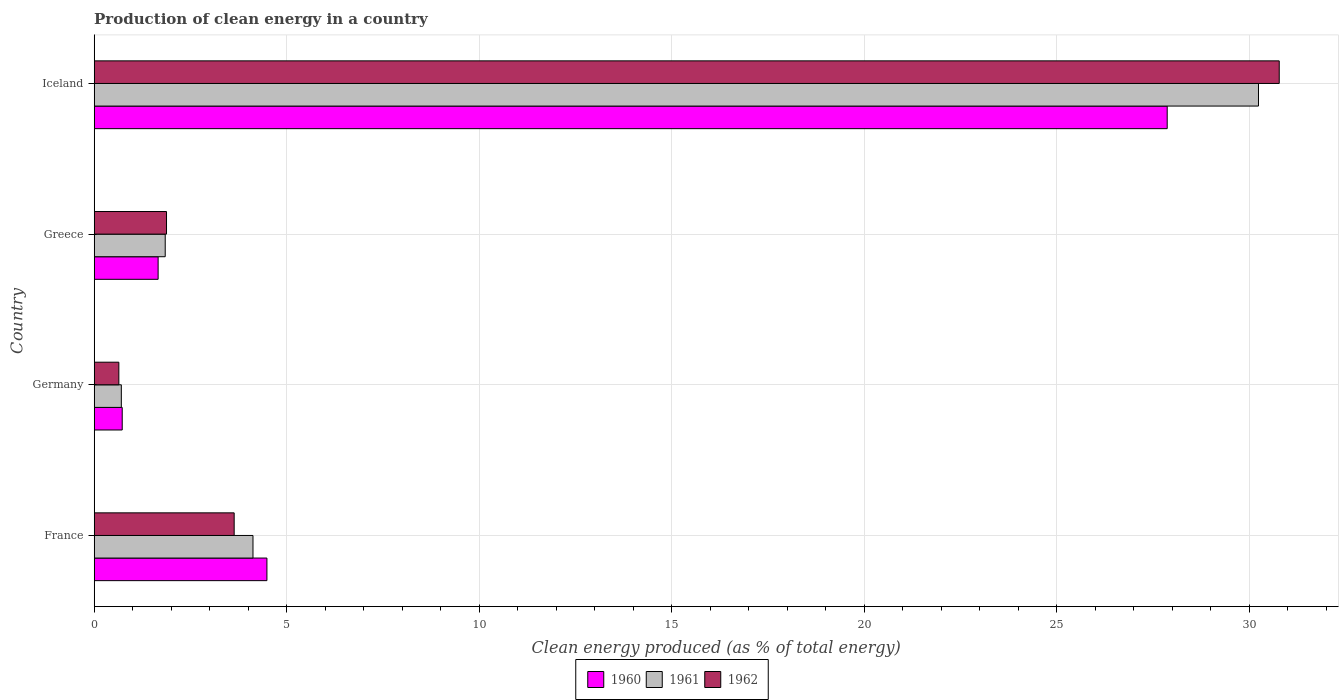How many different coloured bars are there?
Provide a succinct answer. 3. How many groups of bars are there?
Give a very brief answer. 4. How many bars are there on the 3rd tick from the bottom?
Ensure brevity in your answer.  3. In how many cases, is the number of bars for a given country not equal to the number of legend labels?
Your answer should be compact. 0. What is the percentage of clean energy produced in 1961 in Iceland?
Your answer should be very brief. 30.24. Across all countries, what is the maximum percentage of clean energy produced in 1960?
Your answer should be very brief. 27.87. Across all countries, what is the minimum percentage of clean energy produced in 1961?
Provide a succinct answer. 0.7. In which country was the percentage of clean energy produced in 1961 maximum?
Offer a very short reply. Iceland. What is the total percentage of clean energy produced in 1960 in the graph?
Your answer should be very brief. 34.75. What is the difference between the percentage of clean energy produced in 1962 in Germany and that in Iceland?
Keep it short and to the point. -30.14. What is the difference between the percentage of clean energy produced in 1962 in Iceland and the percentage of clean energy produced in 1960 in France?
Make the answer very short. 26.3. What is the average percentage of clean energy produced in 1960 per country?
Ensure brevity in your answer.  8.69. What is the difference between the percentage of clean energy produced in 1961 and percentage of clean energy produced in 1962 in Iceland?
Your answer should be compact. -0.54. In how many countries, is the percentage of clean energy produced in 1961 greater than 11 %?
Offer a very short reply. 1. What is the ratio of the percentage of clean energy produced in 1962 in France to that in Greece?
Ensure brevity in your answer.  1.94. Is the difference between the percentage of clean energy produced in 1961 in Germany and Iceland greater than the difference between the percentage of clean energy produced in 1962 in Germany and Iceland?
Offer a terse response. Yes. What is the difference between the highest and the second highest percentage of clean energy produced in 1960?
Your response must be concise. 23.39. What is the difference between the highest and the lowest percentage of clean energy produced in 1962?
Provide a succinct answer. 30.14. In how many countries, is the percentage of clean energy produced in 1961 greater than the average percentage of clean energy produced in 1961 taken over all countries?
Ensure brevity in your answer.  1. Is the sum of the percentage of clean energy produced in 1962 in Greece and Iceland greater than the maximum percentage of clean energy produced in 1960 across all countries?
Provide a short and direct response. Yes. What is the difference between two consecutive major ticks on the X-axis?
Your answer should be compact. 5. Are the values on the major ticks of X-axis written in scientific E-notation?
Your answer should be compact. No. Does the graph contain grids?
Your answer should be compact. Yes. Where does the legend appear in the graph?
Ensure brevity in your answer.  Bottom center. What is the title of the graph?
Provide a succinct answer. Production of clean energy in a country. What is the label or title of the X-axis?
Provide a succinct answer. Clean energy produced (as % of total energy). What is the label or title of the Y-axis?
Offer a terse response. Country. What is the Clean energy produced (as % of total energy) in 1960 in France?
Your answer should be very brief. 4.49. What is the Clean energy produced (as % of total energy) of 1961 in France?
Keep it short and to the point. 4.12. What is the Clean energy produced (as % of total energy) of 1962 in France?
Give a very brief answer. 3.64. What is the Clean energy produced (as % of total energy) of 1960 in Germany?
Make the answer very short. 0.73. What is the Clean energy produced (as % of total energy) of 1961 in Germany?
Your answer should be compact. 0.7. What is the Clean energy produced (as % of total energy) in 1962 in Germany?
Your response must be concise. 0.64. What is the Clean energy produced (as % of total energy) of 1960 in Greece?
Ensure brevity in your answer.  1.66. What is the Clean energy produced (as % of total energy) in 1961 in Greece?
Provide a short and direct response. 1.84. What is the Clean energy produced (as % of total energy) of 1962 in Greece?
Offer a very short reply. 1.88. What is the Clean energy produced (as % of total energy) in 1960 in Iceland?
Ensure brevity in your answer.  27.87. What is the Clean energy produced (as % of total energy) in 1961 in Iceland?
Offer a very short reply. 30.24. What is the Clean energy produced (as % of total energy) of 1962 in Iceland?
Your answer should be compact. 30.78. Across all countries, what is the maximum Clean energy produced (as % of total energy) in 1960?
Give a very brief answer. 27.87. Across all countries, what is the maximum Clean energy produced (as % of total energy) of 1961?
Offer a very short reply. 30.24. Across all countries, what is the maximum Clean energy produced (as % of total energy) in 1962?
Offer a terse response. 30.78. Across all countries, what is the minimum Clean energy produced (as % of total energy) of 1960?
Your response must be concise. 0.73. Across all countries, what is the minimum Clean energy produced (as % of total energy) of 1961?
Offer a terse response. 0.7. Across all countries, what is the minimum Clean energy produced (as % of total energy) of 1962?
Your response must be concise. 0.64. What is the total Clean energy produced (as % of total energy) in 1960 in the graph?
Provide a short and direct response. 34.75. What is the total Clean energy produced (as % of total energy) of 1961 in the graph?
Provide a succinct answer. 36.92. What is the total Clean energy produced (as % of total energy) in 1962 in the graph?
Provide a succinct answer. 36.94. What is the difference between the Clean energy produced (as % of total energy) of 1960 in France and that in Germany?
Your answer should be very brief. 3.76. What is the difference between the Clean energy produced (as % of total energy) in 1961 in France and that in Germany?
Your answer should be very brief. 3.42. What is the difference between the Clean energy produced (as % of total energy) in 1962 in France and that in Germany?
Your answer should be compact. 3. What is the difference between the Clean energy produced (as % of total energy) in 1960 in France and that in Greece?
Keep it short and to the point. 2.83. What is the difference between the Clean energy produced (as % of total energy) of 1961 in France and that in Greece?
Provide a short and direct response. 2.28. What is the difference between the Clean energy produced (as % of total energy) in 1962 in France and that in Greece?
Keep it short and to the point. 1.76. What is the difference between the Clean energy produced (as % of total energy) of 1960 in France and that in Iceland?
Offer a very short reply. -23.39. What is the difference between the Clean energy produced (as % of total energy) of 1961 in France and that in Iceland?
Your response must be concise. -26.12. What is the difference between the Clean energy produced (as % of total energy) of 1962 in France and that in Iceland?
Ensure brevity in your answer.  -27.15. What is the difference between the Clean energy produced (as % of total energy) of 1960 in Germany and that in Greece?
Give a very brief answer. -0.93. What is the difference between the Clean energy produced (as % of total energy) in 1961 in Germany and that in Greece?
Your response must be concise. -1.14. What is the difference between the Clean energy produced (as % of total energy) of 1962 in Germany and that in Greece?
Provide a succinct answer. -1.24. What is the difference between the Clean energy produced (as % of total energy) in 1960 in Germany and that in Iceland?
Your answer should be very brief. -27.14. What is the difference between the Clean energy produced (as % of total energy) of 1961 in Germany and that in Iceland?
Your answer should be compact. -29.54. What is the difference between the Clean energy produced (as % of total energy) in 1962 in Germany and that in Iceland?
Your answer should be compact. -30.14. What is the difference between the Clean energy produced (as % of total energy) of 1960 in Greece and that in Iceland?
Your answer should be very brief. -26.21. What is the difference between the Clean energy produced (as % of total energy) in 1961 in Greece and that in Iceland?
Provide a short and direct response. -28.4. What is the difference between the Clean energy produced (as % of total energy) of 1962 in Greece and that in Iceland?
Make the answer very short. -28.9. What is the difference between the Clean energy produced (as % of total energy) of 1960 in France and the Clean energy produced (as % of total energy) of 1961 in Germany?
Ensure brevity in your answer.  3.78. What is the difference between the Clean energy produced (as % of total energy) of 1960 in France and the Clean energy produced (as % of total energy) of 1962 in Germany?
Ensure brevity in your answer.  3.85. What is the difference between the Clean energy produced (as % of total energy) of 1961 in France and the Clean energy produced (as % of total energy) of 1962 in Germany?
Keep it short and to the point. 3.48. What is the difference between the Clean energy produced (as % of total energy) of 1960 in France and the Clean energy produced (as % of total energy) of 1961 in Greece?
Keep it short and to the point. 2.64. What is the difference between the Clean energy produced (as % of total energy) of 1960 in France and the Clean energy produced (as % of total energy) of 1962 in Greece?
Your answer should be very brief. 2.61. What is the difference between the Clean energy produced (as % of total energy) in 1961 in France and the Clean energy produced (as % of total energy) in 1962 in Greece?
Your answer should be compact. 2.25. What is the difference between the Clean energy produced (as % of total energy) of 1960 in France and the Clean energy produced (as % of total energy) of 1961 in Iceland?
Make the answer very short. -25.76. What is the difference between the Clean energy produced (as % of total energy) in 1960 in France and the Clean energy produced (as % of total energy) in 1962 in Iceland?
Offer a terse response. -26.3. What is the difference between the Clean energy produced (as % of total energy) in 1961 in France and the Clean energy produced (as % of total energy) in 1962 in Iceland?
Make the answer very short. -26.66. What is the difference between the Clean energy produced (as % of total energy) in 1960 in Germany and the Clean energy produced (as % of total energy) in 1961 in Greece?
Ensure brevity in your answer.  -1.12. What is the difference between the Clean energy produced (as % of total energy) in 1960 in Germany and the Clean energy produced (as % of total energy) in 1962 in Greece?
Your answer should be very brief. -1.15. What is the difference between the Clean energy produced (as % of total energy) in 1961 in Germany and the Clean energy produced (as % of total energy) in 1962 in Greece?
Ensure brevity in your answer.  -1.17. What is the difference between the Clean energy produced (as % of total energy) of 1960 in Germany and the Clean energy produced (as % of total energy) of 1961 in Iceland?
Keep it short and to the point. -29.52. What is the difference between the Clean energy produced (as % of total energy) in 1960 in Germany and the Clean energy produced (as % of total energy) in 1962 in Iceland?
Ensure brevity in your answer.  -30.05. What is the difference between the Clean energy produced (as % of total energy) in 1961 in Germany and the Clean energy produced (as % of total energy) in 1962 in Iceland?
Your answer should be very brief. -30.08. What is the difference between the Clean energy produced (as % of total energy) of 1960 in Greece and the Clean energy produced (as % of total energy) of 1961 in Iceland?
Offer a terse response. -28.58. What is the difference between the Clean energy produced (as % of total energy) of 1960 in Greece and the Clean energy produced (as % of total energy) of 1962 in Iceland?
Provide a short and direct response. -29.12. What is the difference between the Clean energy produced (as % of total energy) in 1961 in Greece and the Clean energy produced (as % of total energy) in 1962 in Iceland?
Make the answer very short. -28.94. What is the average Clean energy produced (as % of total energy) of 1960 per country?
Ensure brevity in your answer.  8.69. What is the average Clean energy produced (as % of total energy) in 1961 per country?
Your answer should be compact. 9.23. What is the average Clean energy produced (as % of total energy) of 1962 per country?
Provide a short and direct response. 9.23. What is the difference between the Clean energy produced (as % of total energy) of 1960 and Clean energy produced (as % of total energy) of 1961 in France?
Offer a terse response. 0.36. What is the difference between the Clean energy produced (as % of total energy) in 1960 and Clean energy produced (as % of total energy) in 1962 in France?
Ensure brevity in your answer.  0.85. What is the difference between the Clean energy produced (as % of total energy) in 1961 and Clean energy produced (as % of total energy) in 1962 in France?
Your response must be concise. 0.49. What is the difference between the Clean energy produced (as % of total energy) of 1960 and Clean energy produced (as % of total energy) of 1961 in Germany?
Your answer should be very brief. 0.02. What is the difference between the Clean energy produced (as % of total energy) of 1960 and Clean energy produced (as % of total energy) of 1962 in Germany?
Offer a very short reply. 0.09. What is the difference between the Clean energy produced (as % of total energy) of 1961 and Clean energy produced (as % of total energy) of 1962 in Germany?
Your response must be concise. 0.06. What is the difference between the Clean energy produced (as % of total energy) of 1960 and Clean energy produced (as % of total energy) of 1961 in Greece?
Your answer should be compact. -0.18. What is the difference between the Clean energy produced (as % of total energy) in 1960 and Clean energy produced (as % of total energy) in 1962 in Greece?
Make the answer very short. -0.22. What is the difference between the Clean energy produced (as % of total energy) of 1961 and Clean energy produced (as % of total energy) of 1962 in Greece?
Ensure brevity in your answer.  -0.03. What is the difference between the Clean energy produced (as % of total energy) in 1960 and Clean energy produced (as % of total energy) in 1961 in Iceland?
Provide a short and direct response. -2.37. What is the difference between the Clean energy produced (as % of total energy) in 1960 and Clean energy produced (as % of total energy) in 1962 in Iceland?
Offer a very short reply. -2.91. What is the difference between the Clean energy produced (as % of total energy) in 1961 and Clean energy produced (as % of total energy) in 1962 in Iceland?
Offer a terse response. -0.54. What is the ratio of the Clean energy produced (as % of total energy) of 1960 in France to that in Germany?
Give a very brief answer. 6.16. What is the ratio of the Clean energy produced (as % of total energy) of 1961 in France to that in Germany?
Offer a terse response. 5.85. What is the ratio of the Clean energy produced (as % of total energy) of 1962 in France to that in Germany?
Provide a short and direct response. 5.68. What is the ratio of the Clean energy produced (as % of total energy) in 1960 in France to that in Greece?
Your answer should be very brief. 2.7. What is the ratio of the Clean energy produced (as % of total energy) of 1961 in France to that in Greece?
Make the answer very short. 2.24. What is the ratio of the Clean energy produced (as % of total energy) in 1962 in France to that in Greece?
Your answer should be compact. 1.94. What is the ratio of the Clean energy produced (as % of total energy) in 1960 in France to that in Iceland?
Provide a short and direct response. 0.16. What is the ratio of the Clean energy produced (as % of total energy) in 1961 in France to that in Iceland?
Your response must be concise. 0.14. What is the ratio of the Clean energy produced (as % of total energy) in 1962 in France to that in Iceland?
Provide a short and direct response. 0.12. What is the ratio of the Clean energy produced (as % of total energy) of 1960 in Germany to that in Greece?
Your response must be concise. 0.44. What is the ratio of the Clean energy produced (as % of total energy) in 1961 in Germany to that in Greece?
Make the answer very short. 0.38. What is the ratio of the Clean energy produced (as % of total energy) of 1962 in Germany to that in Greece?
Provide a short and direct response. 0.34. What is the ratio of the Clean energy produced (as % of total energy) of 1960 in Germany to that in Iceland?
Give a very brief answer. 0.03. What is the ratio of the Clean energy produced (as % of total energy) of 1961 in Germany to that in Iceland?
Offer a terse response. 0.02. What is the ratio of the Clean energy produced (as % of total energy) of 1962 in Germany to that in Iceland?
Your answer should be compact. 0.02. What is the ratio of the Clean energy produced (as % of total energy) in 1960 in Greece to that in Iceland?
Your answer should be compact. 0.06. What is the ratio of the Clean energy produced (as % of total energy) of 1961 in Greece to that in Iceland?
Offer a very short reply. 0.06. What is the ratio of the Clean energy produced (as % of total energy) in 1962 in Greece to that in Iceland?
Keep it short and to the point. 0.06. What is the difference between the highest and the second highest Clean energy produced (as % of total energy) of 1960?
Your answer should be very brief. 23.39. What is the difference between the highest and the second highest Clean energy produced (as % of total energy) of 1961?
Keep it short and to the point. 26.12. What is the difference between the highest and the second highest Clean energy produced (as % of total energy) in 1962?
Your answer should be compact. 27.15. What is the difference between the highest and the lowest Clean energy produced (as % of total energy) of 1960?
Provide a succinct answer. 27.14. What is the difference between the highest and the lowest Clean energy produced (as % of total energy) of 1961?
Provide a short and direct response. 29.54. What is the difference between the highest and the lowest Clean energy produced (as % of total energy) in 1962?
Offer a very short reply. 30.14. 